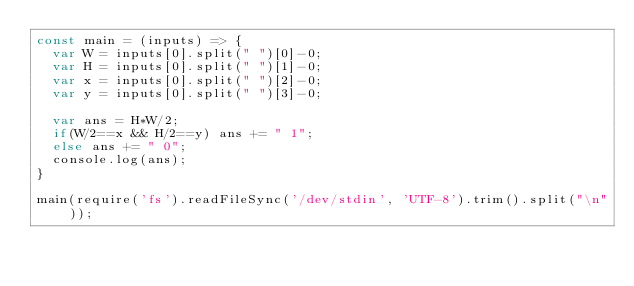Convert code to text. <code><loc_0><loc_0><loc_500><loc_500><_JavaScript_>const main = (inputs) => {
  var W = inputs[0].split(" ")[0]-0;
  var H = inputs[0].split(" ")[1]-0;
  var x = inputs[0].split(" ")[2]-0;
  var y = inputs[0].split(" ")[3]-0;

  var ans = H*W/2;
  if(W/2==x && H/2==y) ans += " 1";
  else ans += " 0";
  console.log(ans);
}

main(require('fs').readFileSync('/dev/stdin', 'UTF-8').trim().split("\n"));
</code> 